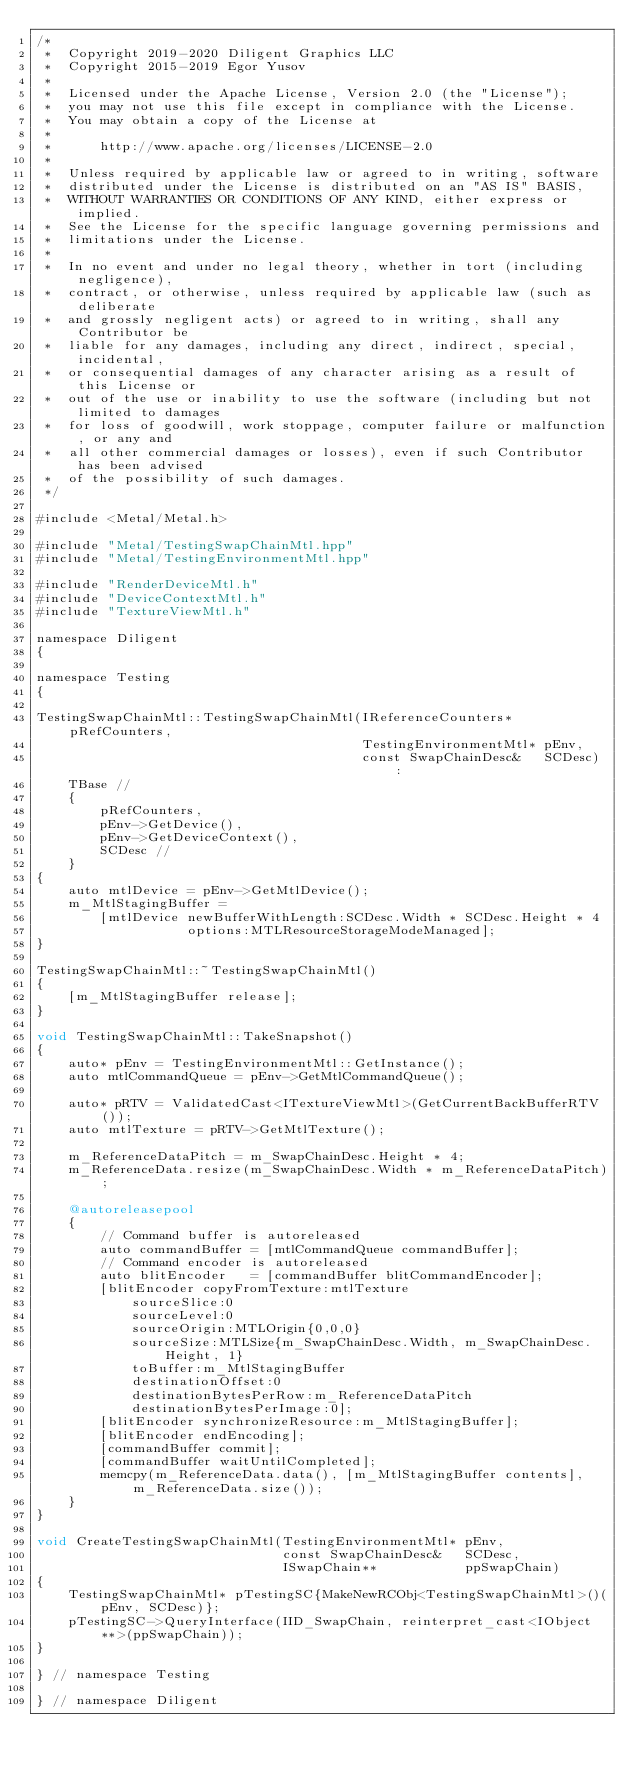Convert code to text. <code><loc_0><loc_0><loc_500><loc_500><_ObjectiveC_>/*
 *  Copyright 2019-2020 Diligent Graphics LLC
 *  Copyright 2015-2019 Egor Yusov
 *  
 *  Licensed under the Apache License, Version 2.0 (the "License");
 *  you may not use this file except in compliance with the License.
 *  You may obtain a copy of the License at
 *  
 *      http://www.apache.org/licenses/LICENSE-2.0
 *  
 *  Unless required by applicable law or agreed to in writing, software
 *  distributed under the License is distributed on an "AS IS" BASIS,
 *  WITHOUT WARRANTIES OR CONDITIONS OF ANY KIND, either express or implied.
 *  See the License for the specific language governing permissions and
 *  limitations under the License.
 *
 *  In no event and under no legal theory, whether in tort (including negligence), 
 *  contract, or otherwise, unless required by applicable law (such as deliberate 
 *  and grossly negligent acts) or agreed to in writing, shall any Contributor be
 *  liable for any damages, including any direct, indirect, special, incidental, 
 *  or consequential damages of any character arising as a result of this License or 
 *  out of the use or inability to use the software (including but not limited to damages 
 *  for loss of goodwill, work stoppage, computer failure or malfunction, or any and 
 *  all other commercial damages or losses), even if such Contributor has been advised 
 *  of the possibility of such damages.
 */

#include <Metal/Metal.h>

#include "Metal/TestingSwapChainMtl.hpp"
#include "Metal/TestingEnvironmentMtl.hpp"

#include "RenderDeviceMtl.h"
#include "DeviceContextMtl.h"
#include "TextureViewMtl.h"

namespace Diligent
{

namespace Testing
{

TestingSwapChainMtl::TestingSwapChainMtl(IReferenceCounters*    pRefCounters,
                                         TestingEnvironmentMtl* pEnv,
                                         const SwapChainDesc&   SCDesc) :
    TBase //
    {
        pRefCounters,
        pEnv->GetDevice(),
        pEnv->GetDeviceContext(),
        SCDesc //
    }
{
    auto mtlDevice = pEnv->GetMtlDevice();
    m_MtlStagingBuffer =
        [mtlDevice newBufferWithLength:SCDesc.Width * SCDesc.Height * 4
                   options:MTLResourceStorageModeManaged];
}

TestingSwapChainMtl::~TestingSwapChainMtl()
{
    [m_MtlStagingBuffer release];
}

void TestingSwapChainMtl::TakeSnapshot()
{
    auto* pEnv = TestingEnvironmentMtl::GetInstance();
    auto mtlCommandQueue = pEnv->GetMtlCommandQueue();

    auto* pRTV = ValidatedCast<ITextureViewMtl>(GetCurrentBackBufferRTV());
    auto mtlTexture = pRTV->GetMtlTexture();

    m_ReferenceDataPitch = m_SwapChainDesc.Height * 4;
    m_ReferenceData.resize(m_SwapChainDesc.Width * m_ReferenceDataPitch);

    @autoreleasepool
    {
        // Command buffer is autoreleased
        auto commandBuffer = [mtlCommandQueue commandBuffer];
        // Command encoder is autoreleased
        auto blitEncoder   = [commandBuffer blitCommandEncoder];
        [blitEncoder copyFromTexture:mtlTexture
            sourceSlice:0
            sourceLevel:0
            sourceOrigin:MTLOrigin{0,0,0}
            sourceSize:MTLSize{m_SwapChainDesc.Width, m_SwapChainDesc.Height, 1}
            toBuffer:m_MtlStagingBuffer
            destinationOffset:0
            destinationBytesPerRow:m_ReferenceDataPitch
            destinationBytesPerImage:0];
        [blitEncoder synchronizeResource:m_MtlStagingBuffer];
        [blitEncoder endEncoding];
        [commandBuffer commit];
        [commandBuffer waitUntilCompleted];
        memcpy(m_ReferenceData.data(), [m_MtlStagingBuffer contents], m_ReferenceData.size());
    }
}

void CreateTestingSwapChainMtl(TestingEnvironmentMtl* pEnv,
                               const SwapChainDesc&   SCDesc,
                               ISwapChain**           ppSwapChain)
{
    TestingSwapChainMtl* pTestingSC{MakeNewRCObj<TestingSwapChainMtl>()(pEnv, SCDesc)};
    pTestingSC->QueryInterface(IID_SwapChain, reinterpret_cast<IObject**>(ppSwapChain));
}

} // namespace Testing

} // namespace Diligent
</code> 